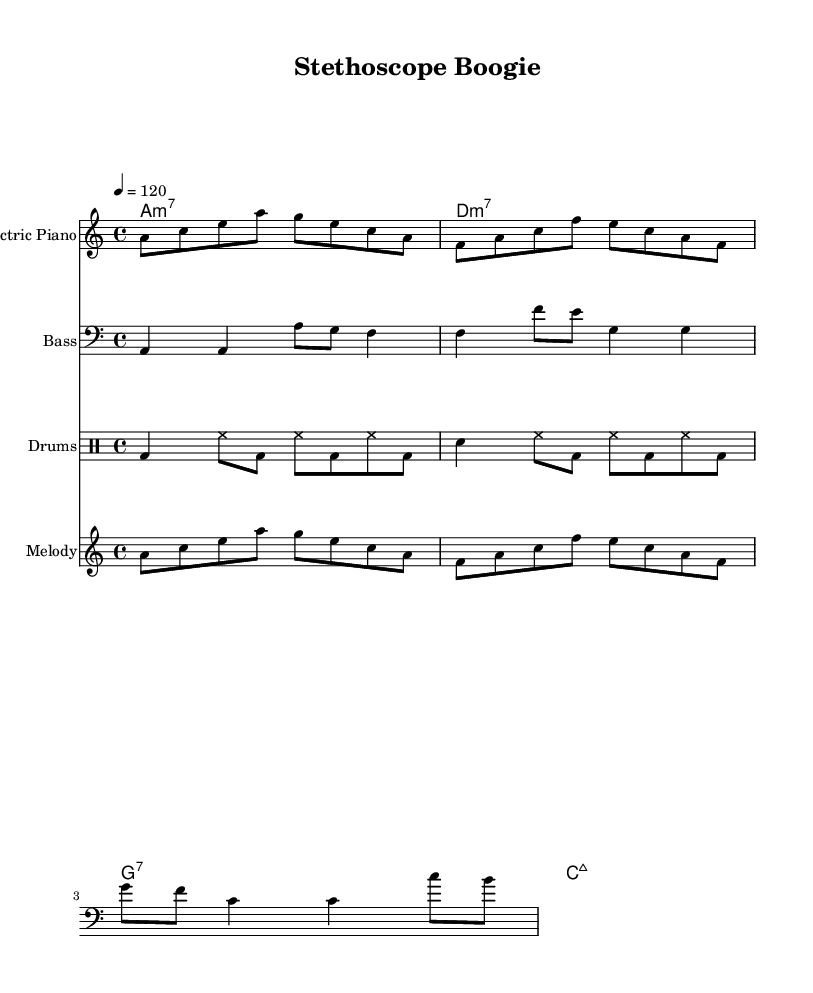What is the key signature of this music? The key signature is A minor, which has no sharps or flats.
Answer: A minor What is the time signature of this music? The time signature is indicated by the fraction at the beginning, which shows there are four beats in a measure and the quarter note gets one beat.
Answer: 4/4 What is the tempo marking for this piece? The tempo marking shows a value of 120 beats per minute, which indicates a moderate speed for the piece.
Answer: 120 How many measures are there in the melody? By counting the individual groups of notes in the melody part, we find there are four measures total.
Answer: 4 What kind of chord is played in the first measure of the harmonies? The first measure has an A minor 7 chord, as indicated by the chord symbol written above the staff.
Answer: A minor 7 What instruments are included in this piece? The score shows four distinct instrumental parts: electric piano, bass, drums, and melody.
Answer: Electric piano, bass, drums, melody Which genre does this piece represent? The upbeat and rhythmic characteristics, along with the thematic lyrics, indicate that this piece is categorized as a disco track.
Answer: Disco 